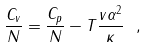<formula> <loc_0><loc_0><loc_500><loc_500>\frac { C _ { v } } { N } = \frac { C _ { p } } { N } - T \frac { v \alpha ^ { 2 } } { \kappa } \ ,</formula> 